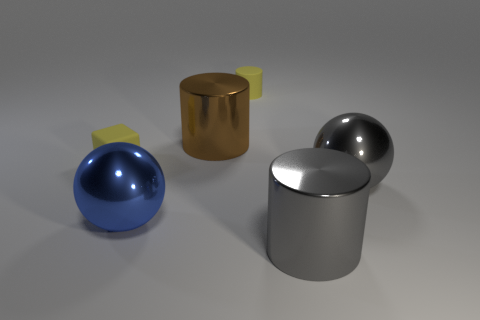Add 1 metallic spheres. How many objects exist? 7 Subtract all big metal cylinders. How many cylinders are left? 1 Subtract all yellow cylinders. How many cylinders are left? 2 Subtract 1 cylinders. How many cylinders are left? 2 Subtract all balls. How many objects are left? 4 Subtract all blue cubes. Subtract all gray cylinders. How many cubes are left? 1 Subtract all yellow cylinders. How many red cubes are left? 0 Subtract all small objects. Subtract all large balls. How many objects are left? 2 Add 4 large gray metal balls. How many large gray metal balls are left? 5 Add 1 big gray things. How many big gray things exist? 3 